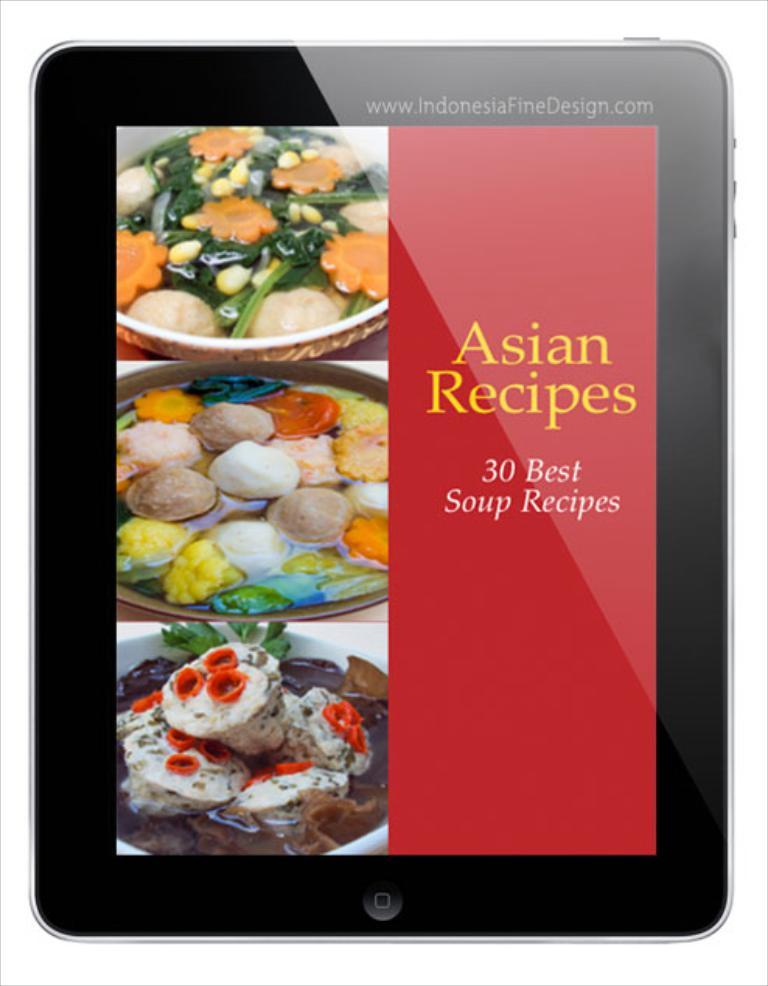What is the main subject of the image? The main subject of the image is a tab. What can be found on the tab? The tab contains text. What is inside the tab? There are bowls in the tab. What is inside the bowls? The bowls contain food items. What scent can be detected from the tab in the image? There is no information about the scent of the tab in the image, as it only contains text and bowls with food items. 